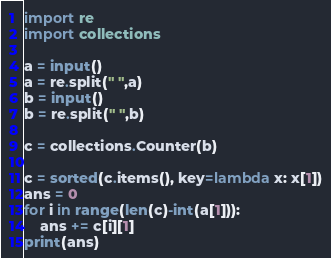<code> <loc_0><loc_0><loc_500><loc_500><_Python_>import re
import collections

a = input()
a = re.split(" ",a)
b = input()
b = re.split(" ",b)

c = collections.Counter(b)

c = sorted(c.items(), key=lambda x: x[1])
ans = 0
for i in range(len(c)-int(a[1])):
    ans += c[i][1]
print(ans)</code> 